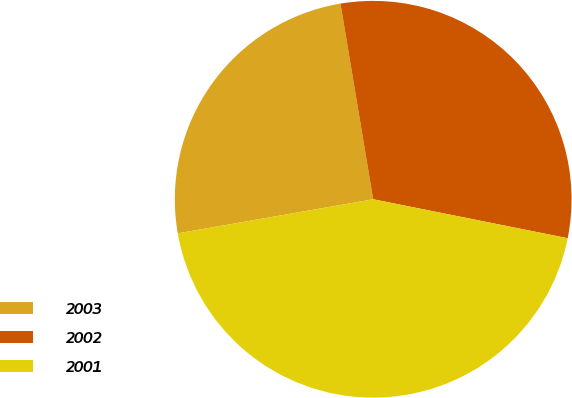Convert chart to OTSL. <chart><loc_0><loc_0><loc_500><loc_500><pie_chart><fcel>2003<fcel>2002<fcel>2001<nl><fcel>25.11%<fcel>30.78%<fcel>44.1%<nl></chart> 